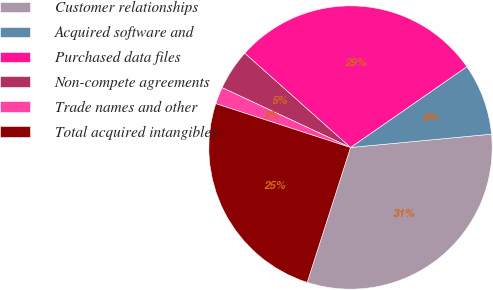Convert chart. <chart><loc_0><loc_0><loc_500><loc_500><pie_chart><fcel>Customer relationships<fcel>Acquired software and<fcel>Purchased data files<fcel>Non-compete agreements<fcel>Trade names and other<fcel>Total acquired intangibles<nl><fcel>31.45%<fcel>8.16%<fcel>28.75%<fcel>4.64%<fcel>1.94%<fcel>25.06%<nl></chart> 